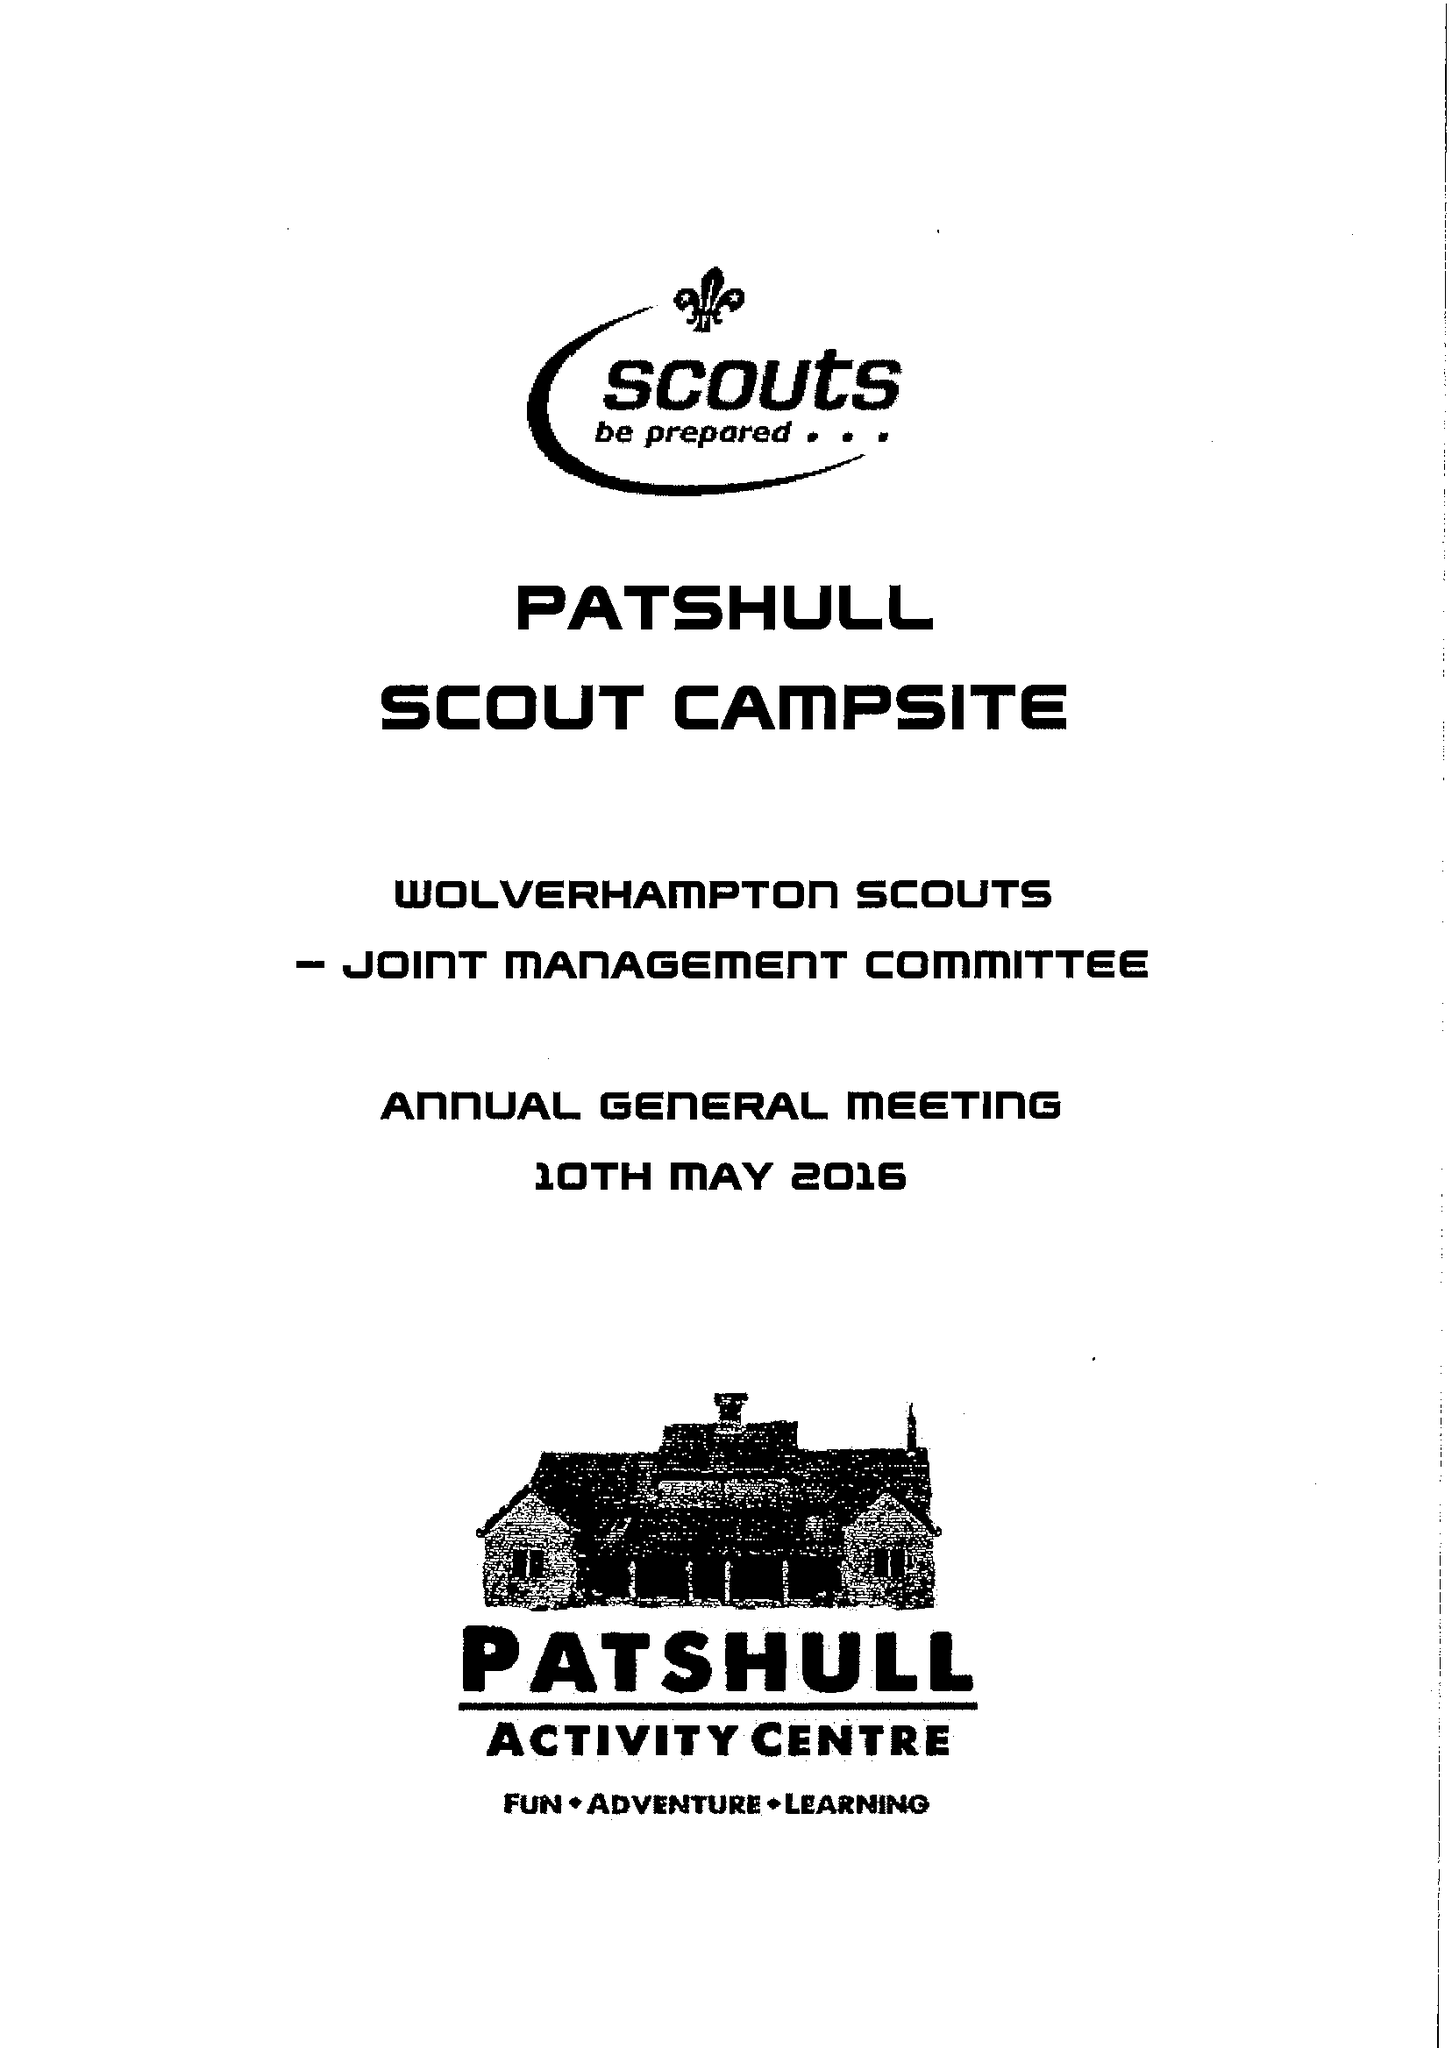What is the value for the address__postcode?
Answer the question using a single word or phrase. WV11 1NR 